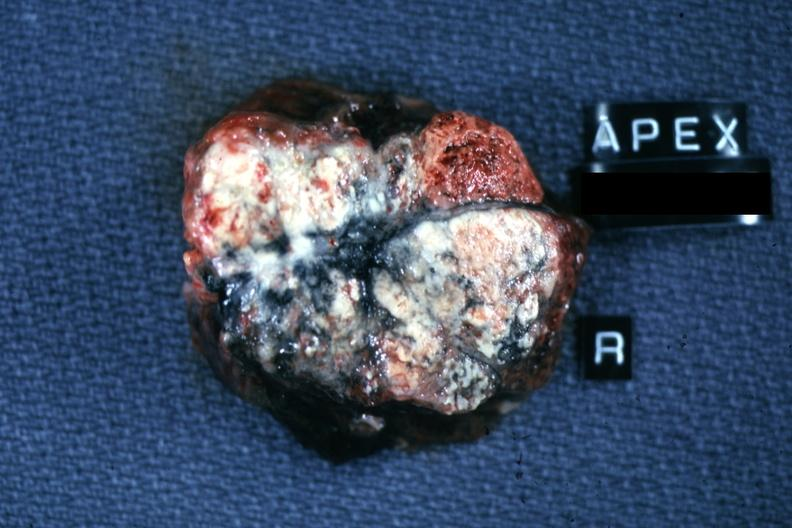s nodular tumor present?
Answer the question using a single word or phrase. No 